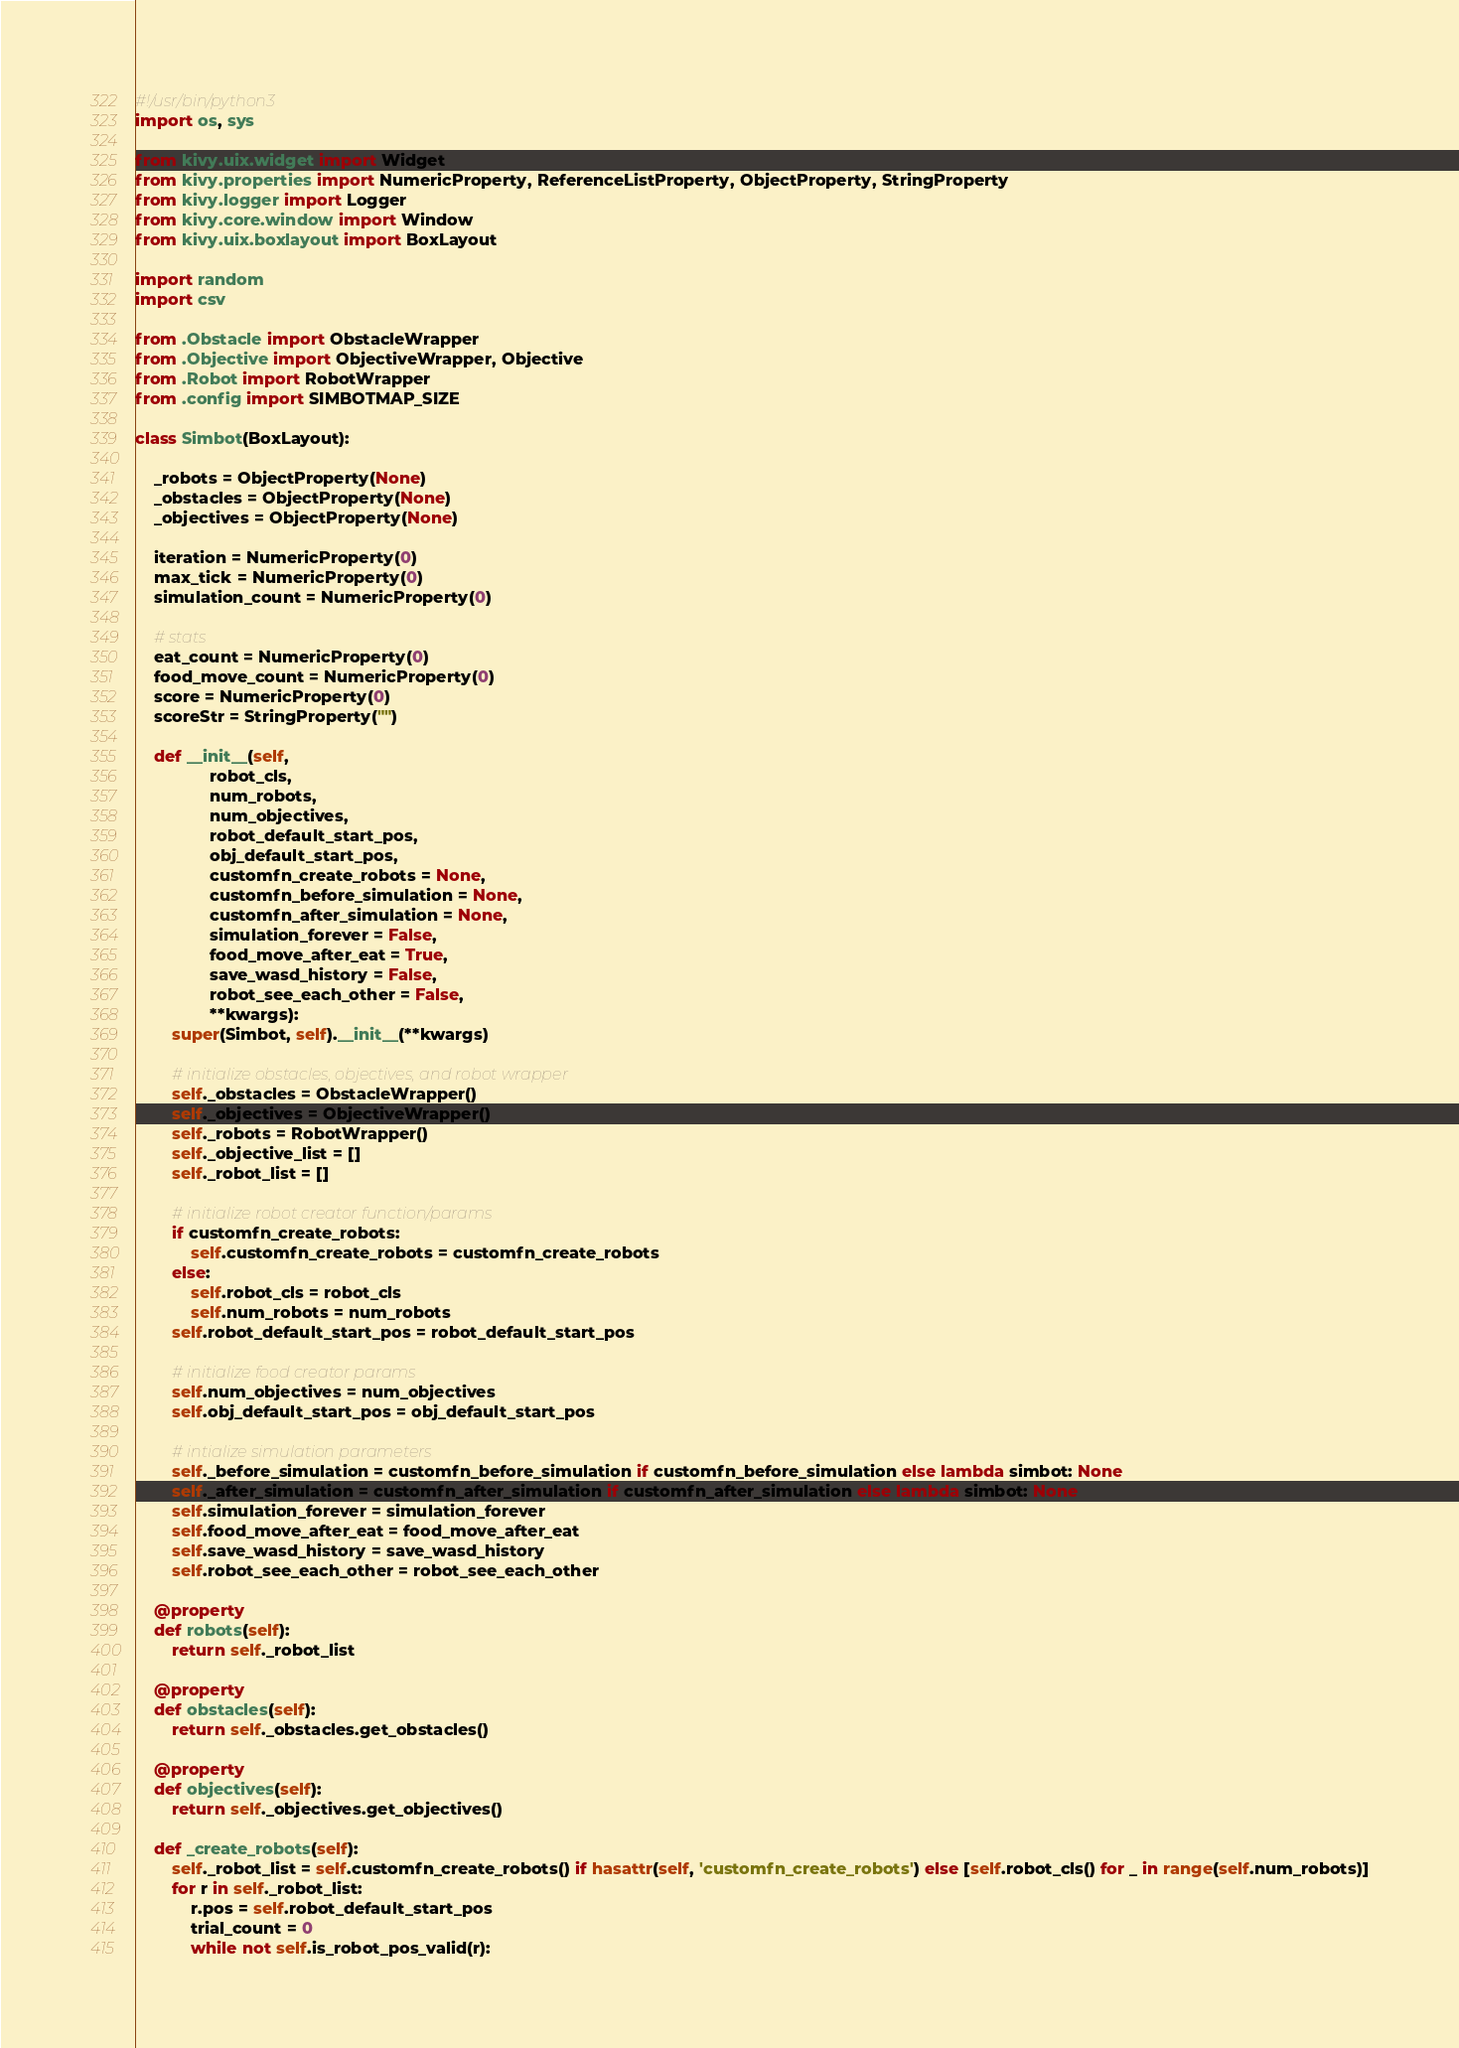Convert code to text. <code><loc_0><loc_0><loc_500><loc_500><_Python_>#!/usr/bin/python3
import os, sys

from kivy.uix.widget import Widget
from kivy.properties import NumericProperty, ReferenceListProperty, ObjectProperty, StringProperty
from kivy.logger import Logger
from kivy.core.window import Window
from kivy.uix.boxlayout import BoxLayout

import random
import csv

from .Obstacle import ObstacleWrapper
from .Objective import ObjectiveWrapper, Objective
from .Robot import RobotWrapper
from .config import SIMBOTMAP_SIZE

class Simbot(BoxLayout):
    
    _robots = ObjectProperty(None)
    _obstacles = ObjectProperty(None)
    _objectives = ObjectProperty(None)

    iteration = NumericProperty(0)
    max_tick = NumericProperty(0)
    simulation_count = NumericProperty(0)

    # stats
    eat_count = NumericProperty(0)
    food_move_count = NumericProperty(0)
    score = NumericProperty(0)
    scoreStr = StringProperty("")

    def __init__(self, 
                robot_cls, 
                num_robots, 
                num_objectives,
                robot_default_start_pos,
                obj_default_start_pos,
                customfn_create_robots = None, 
                customfn_before_simulation = None,
                customfn_after_simulation = None,
                simulation_forever = False,
                food_move_after_eat = True,
                save_wasd_history = False,
                robot_see_each_other = False,
                **kwargs):
        super(Simbot, self).__init__(**kwargs)

        # initialize obstacles, objectives, and robot wrapper
        self._obstacles = ObstacleWrapper()
        self._objectives = ObjectiveWrapper()
        self._robots = RobotWrapper()
        self._objective_list = []
        self._robot_list = []

        # initialize robot creator function/params
        if customfn_create_robots:
            self.customfn_create_robots = customfn_create_robots
        else:
            self.robot_cls = robot_cls
            self.num_robots = num_robots    
        self.robot_default_start_pos = robot_default_start_pos

        # initialize food creator params
        self.num_objectives = num_objectives
        self.obj_default_start_pos = obj_default_start_pos

        # intialize simulation parameters
        self._before_simulation = customfn_before_simulation if customfn_before_simulation else lambda simbot: None
        self._after_simulation = customfn_after_simulation if customfn_after_simulation else lambda simbot: None
        self.simulation_forever = simulation_forever
        self.food_move_after_eat = food_move_after_eat
        self.save_wasd_history = save_wasd_history
        self.robot_see_each_other = robot_see_each_other
    
    @property
    def robots(self):
        return self._robot_list

    @property
    def obstacles(self):
        return self._obstacles.get_obstacles()

    @property
    def objectives(self):
        return self._objectives.get_objectives()

    def _create_robots(self):
        self._robot_list = self.customfn_create_robots() if hasattr(self, 'customfn_create_robots') else [self.robot_cls() for _ in range(self.num_robots)]
        for r in self._robot_list:
            r.pos = self.robot_default_start_pos
            trial_count = 0
            while not self.is_robot_pos_valid(r):</code> 